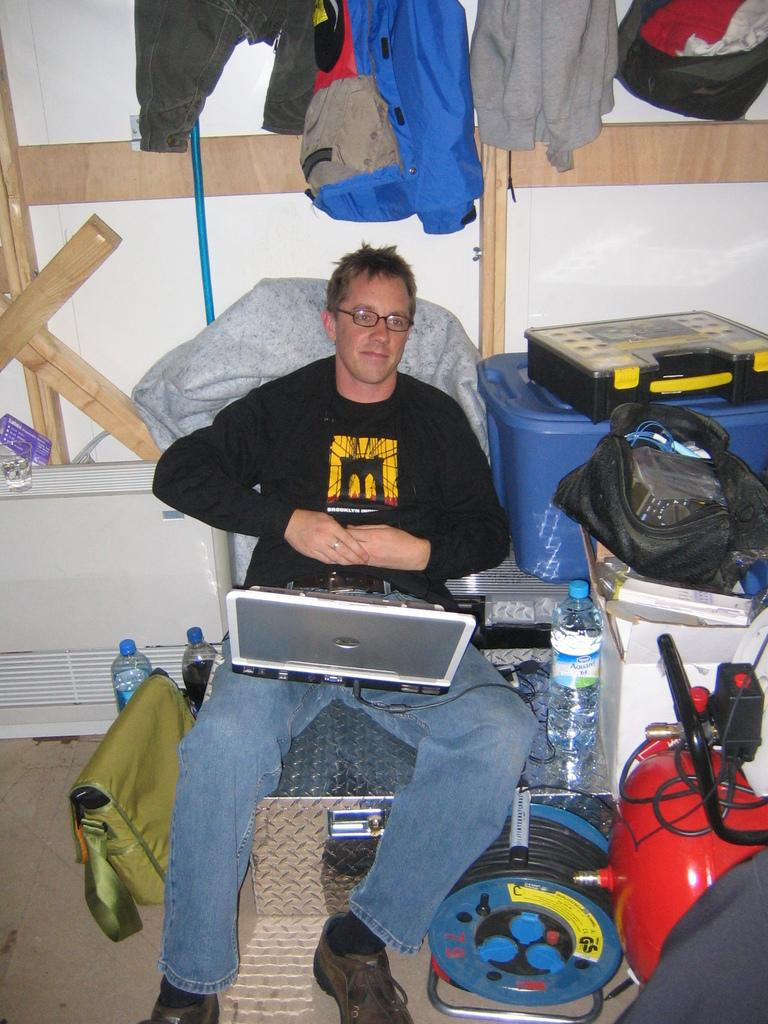What is the man in the image doing? There is a man sitting in the image. What else can be seen in the image besides the man? There are clothes and water bottles visible in the image. Can you describe any other objects present in the image? There are some other objects in the image. What type of mint plant can be seen growing in the image? There is no mint plant present in the image. What kind of noise can be heard coming from the objects in the image? There is no reference to any noise in the image, as it only features a man sitting, clothes, and water bottles. 